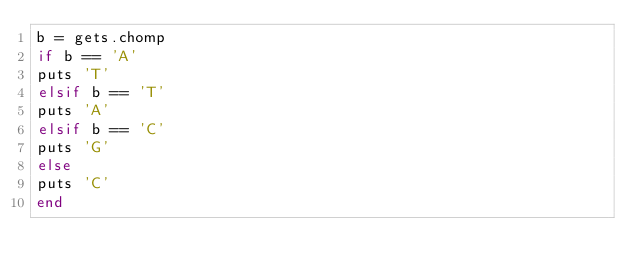<code> <loc_0><loc_0><loc_500><loc_500><_Ruby_>b = gets.chomp
if b == 'A'
puts 'T'
elsif b == 'T'
puts 'A'
elsif b == 'C'
puts 'G'
else
puts 'C'
end
</code> 